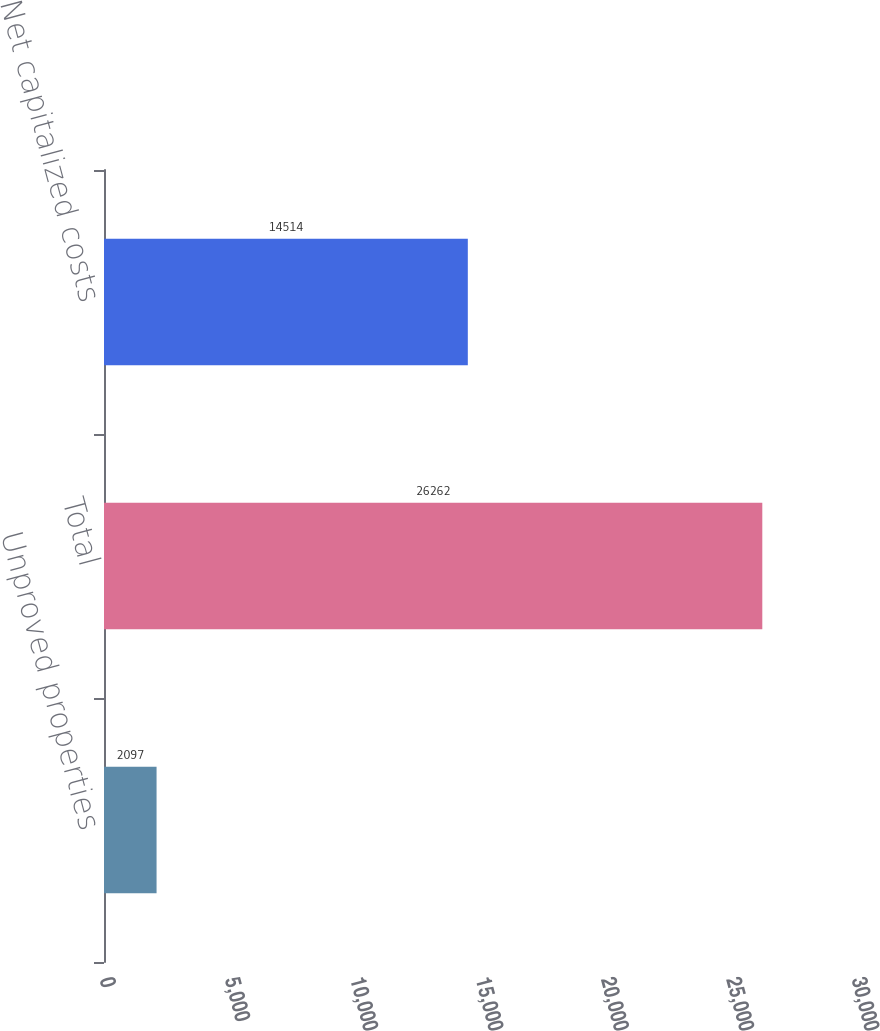Convert chart to OTSL. <chart><loc_0><loc_0><loc_500><loc_500><bar_chart><fcel>Unproved properties<fcel>Total<fcel>Net capitalized costs<nl><fcel>2097<fcel>26262<fcel>14514<nl></chart> 